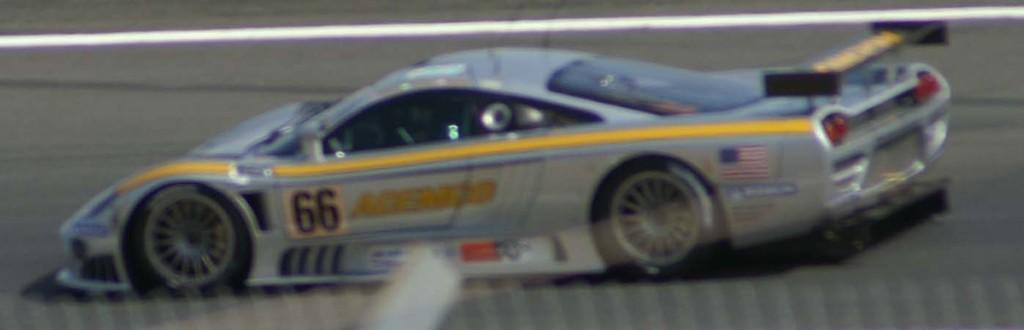Could you give a brief overview of what you see in this image? In this picture we can see the blur image of a racing car on the road with a white line. 